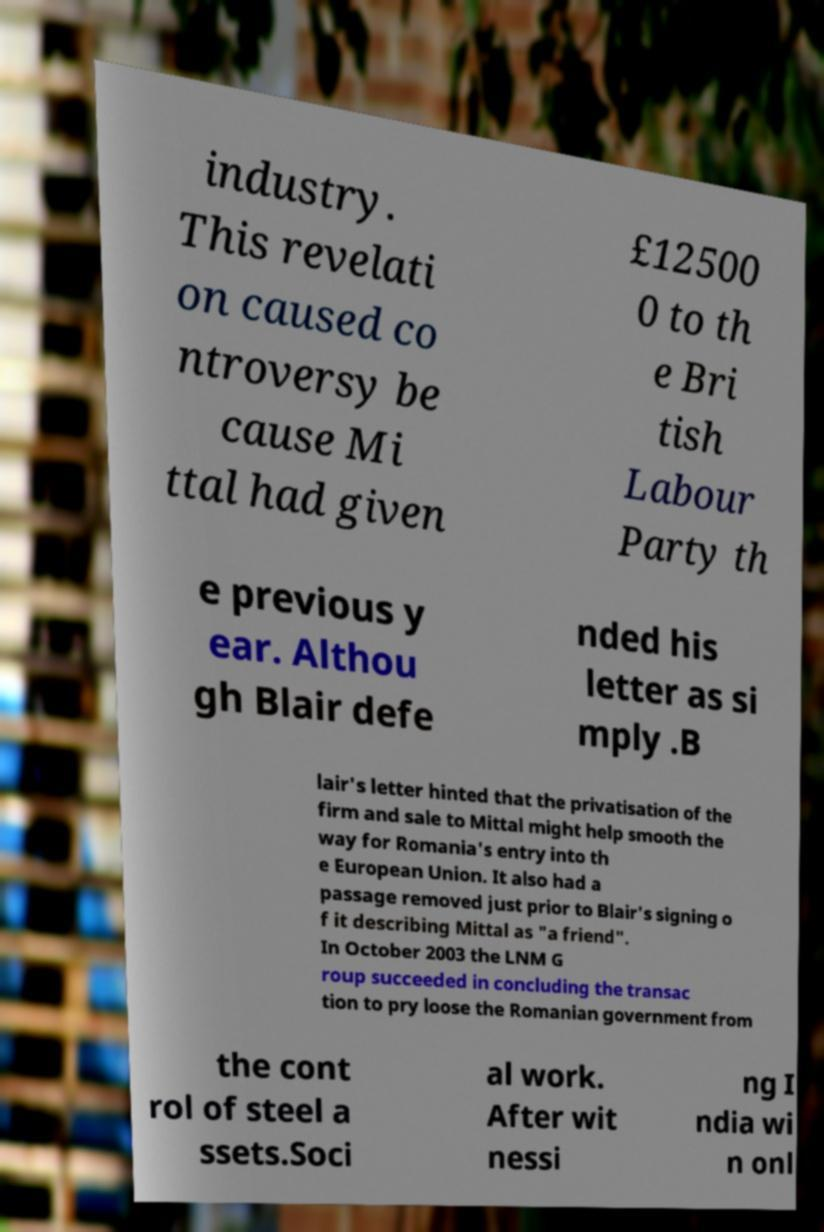Could you extract and type out the text from this image? industry. This revelati on caused co ntroversy be cause Mi ttal had given £12500 0 to th e Bri tish Labour Party th e previous y ear. Althou gh Blair defe nded his letter as si mply .B lair's letter hinted that the privatisation of the firm and sale to Mittal might help smooth the way for Romania's entry into th e European Union. It also had a passage removed just prior to Blair's signing o f it describing Mittal as "a friend". In October 2003 the LNM G roup succeeded in concluding the transac tion to pry loose the Romanian government from the cont rol of steel a ssets.Soci al work. After wit nessi ng I ndia wi n onl 